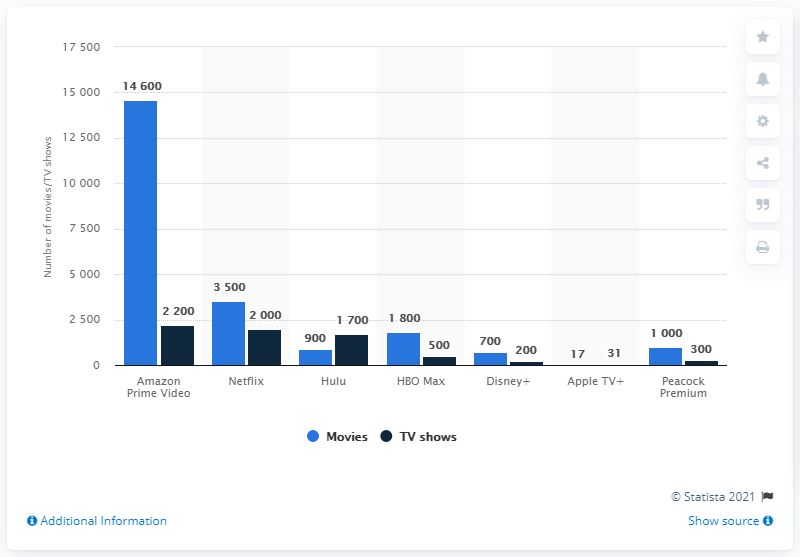List a handful of essential elements in this visual. Amazon Prime Video had the largest content catalog of movies and TV shows in the United States. As of the current date, there are 17 movies available for streaming on Apple TV+. 